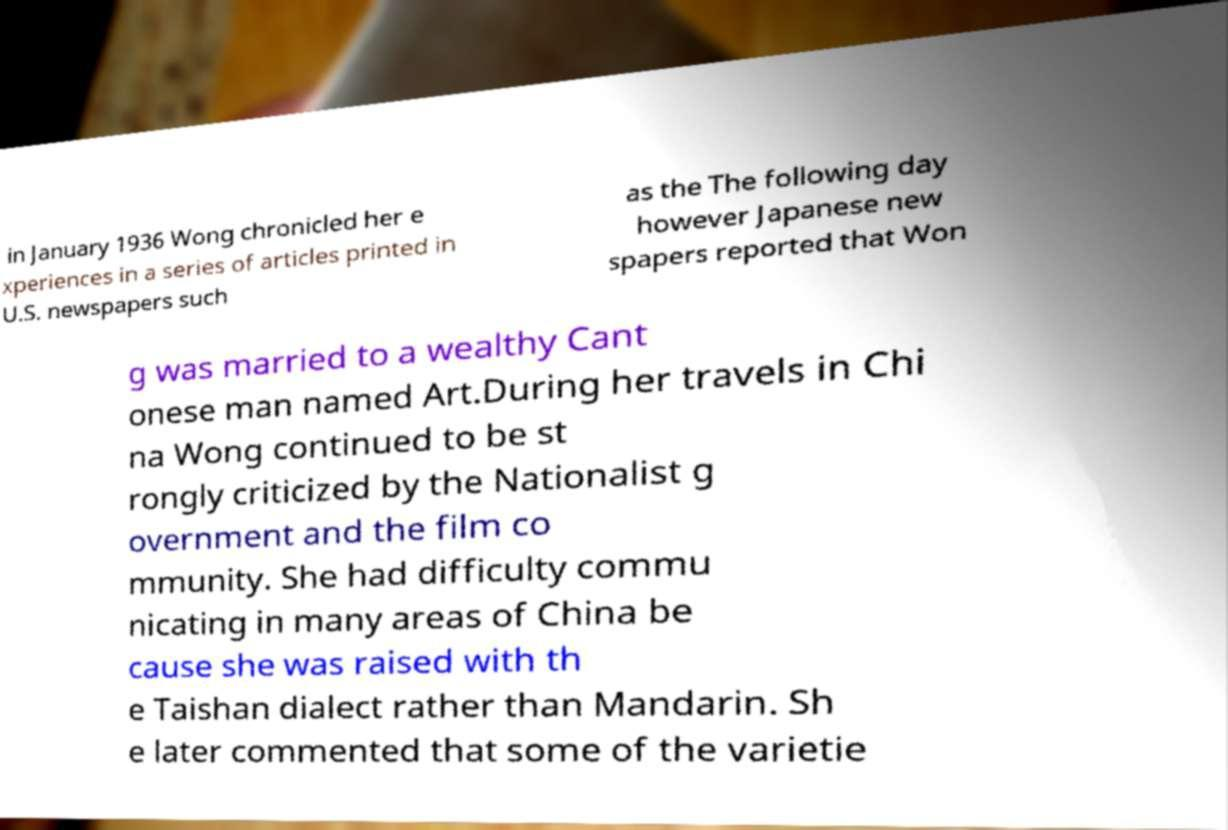Please identify and transcribe the text found in this image. in January 1936 Wong chronicled her e xperiences in a series of articles printed in U.S. newspapers such as the The following day however Japanese new spapers reported that Won g was married to a wealthy Cant onese man named Art.During her travels in Chi na Wong continued to be st rongly criticized by the Nationalist g overnment and the film co mmunity. She had difficulty commu nicating in many areas of China be cause she was raised with th e Taishan dialect rather than Mandarin. Sh e later commented that some of the varietie 